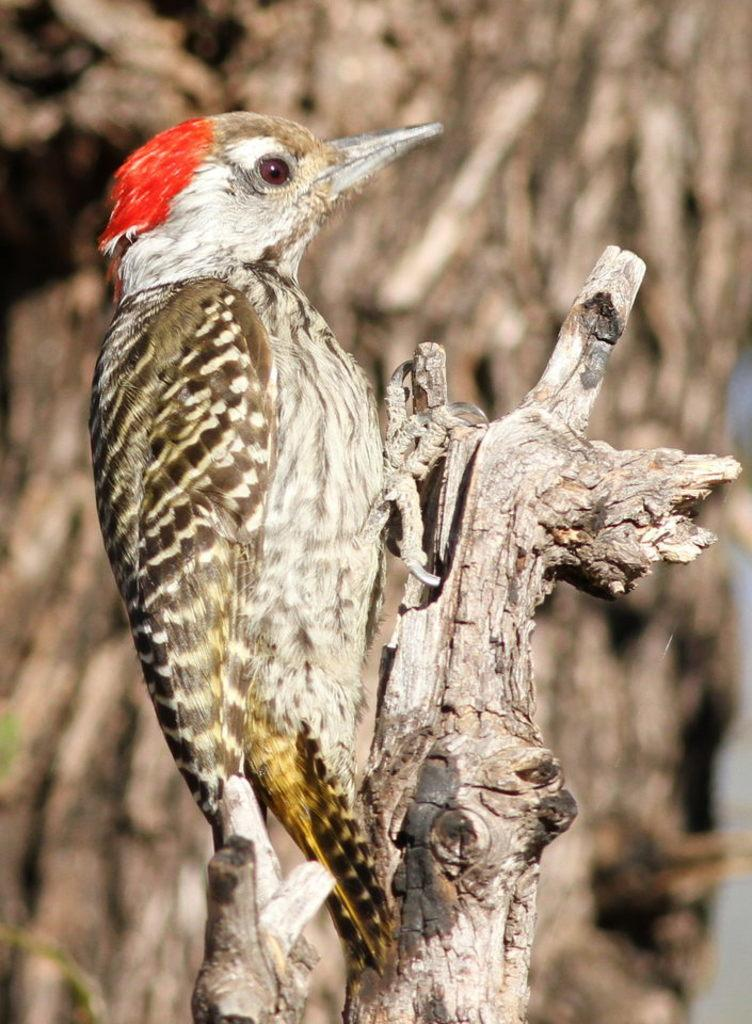What type of bird is in the image? There is a red-headed woodpecker in the image. What is the woodpecker standing on? The woodpecker is standing on wood. What can be seen in the background of the image? There is a tree visible in the background of the image. What type of scarf is the woodpecker wearing in the image? There is no scarf present in the image; the woodpecker is a bird and does not wear clothing. 